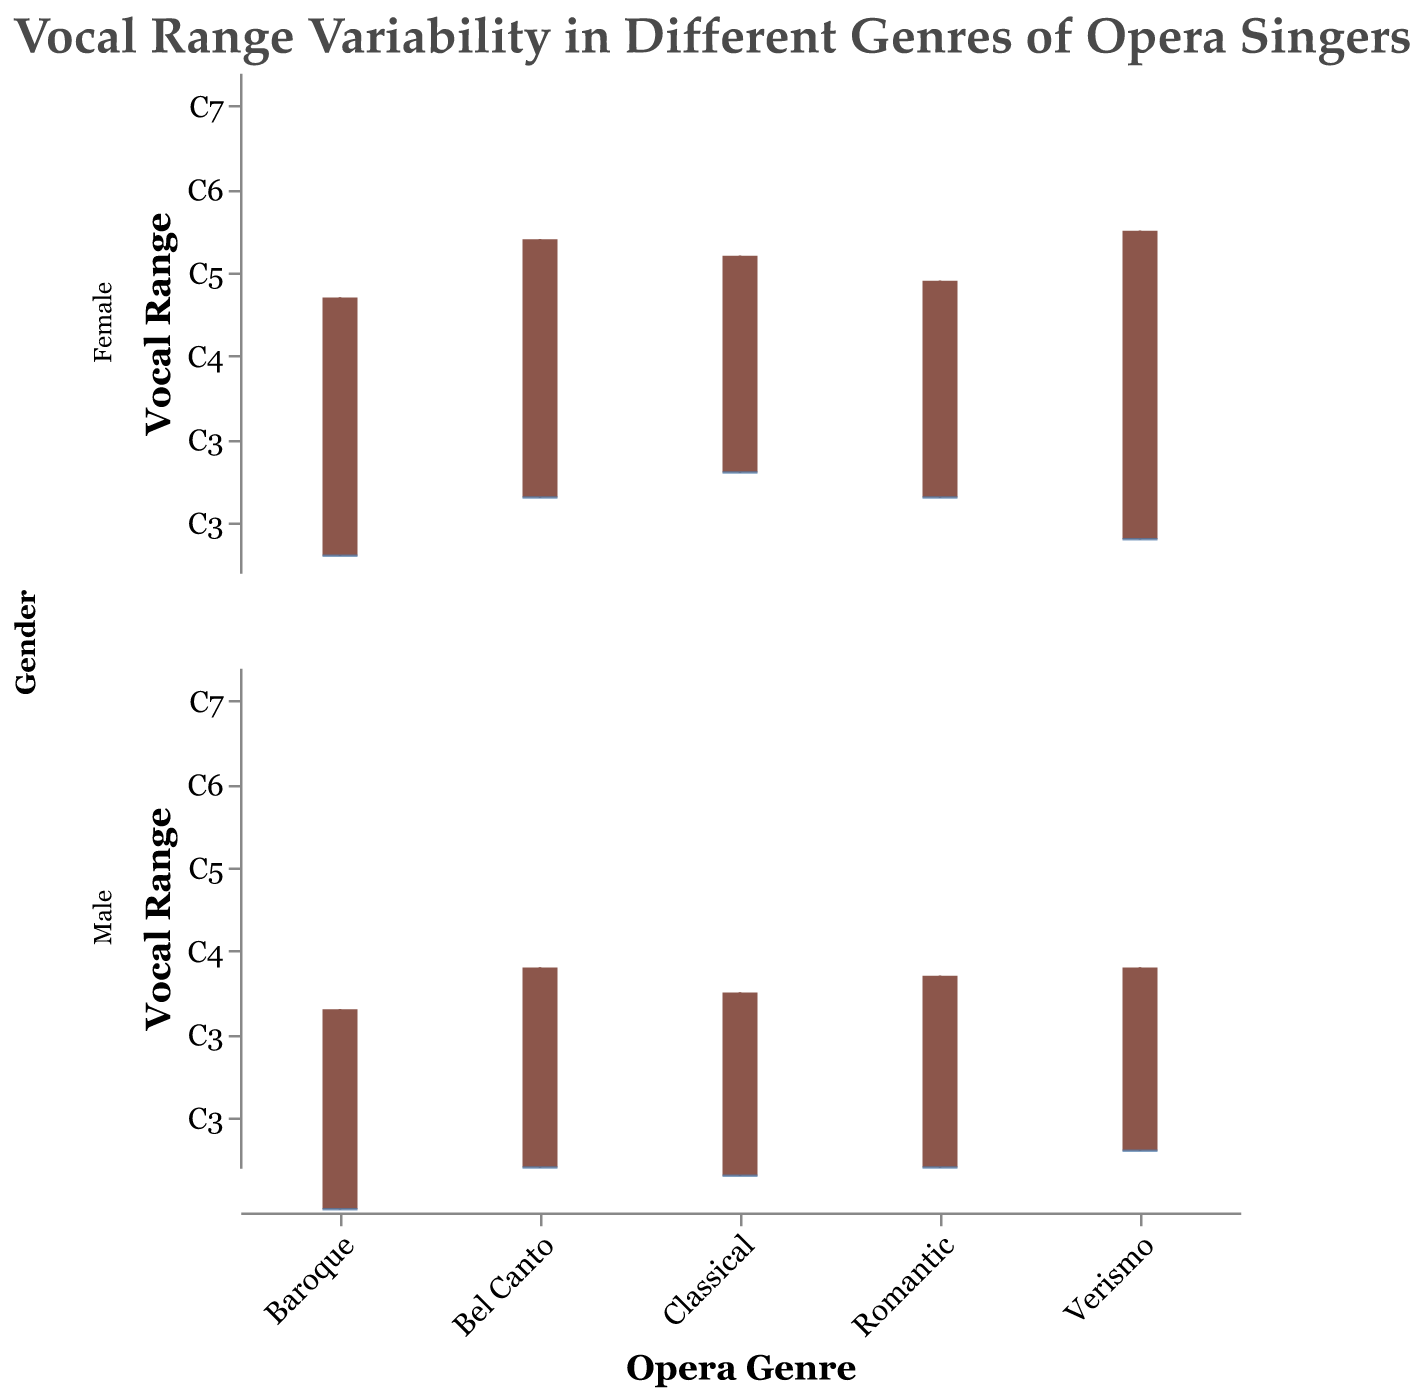Which opera genre has the widest vocal range for female singers? By looking at the box plots for female singers, we compare the lengths of the boxes in each genre. Verismo (Maria Callas) has the widest range extending from E3 to F6.
Answer: Verismo What is the average upper note for male singers across all genres? Listing out the upper notes for male singers: C5, G4, A4, B4, C5. Converting these letters to their numerical equivalents: 60, 55, 69, 71, 72. Summing these values: 60 + 55 + 69 + 71 + 72 = 327. Dividing by 5 (the number of male singers) gives an average of 65.4, which corresponds to the range between C4 and D4.
Answer: 65.4 (C4-D4) Which gender has a more extensive overall vocal range in the "Romantic" genre? For female singers (Angela Gheorghiu), vocal range is from A3 to B5. For male singers (Jonas Kaufmann), the range is from C3 to B4. Comparing total range: Female range (A3-B5) spans more notes than male range (C3-B4).
Answer: Female Are there any genres where the vocal ranges of male and female singers overlap completely? By looking at each genre and comparing male and female vocal ranges:
- Bel Canto: No overlap between C3-C5 for male and A3-E6 for female.
- Baroque: No overlap between G2-G4 for male and D3-A5 for female.
- Classical: No overlap between B2-A4 for male and C4-D6 for female.
- Romantic: No overlap between C3-B4 for male and A3-B5 for female.
- Verismo: Both ranges partly overlap (D3-C5 for male and E3-F6 for female). 
No complete overlaps but partial in Verismo.
Answer: No complete overlaps In which genre do male singers have the narrowest vocal range? Identify the narrowest box plot for male singers:
- Bel Canto: C3-C5
- Baroque: G2-G4
- Classical: B2-A4
- Romantic: C3-B4
- Verismo: D3-C5
Baroque (Andreas Scholl) has the narrowest range with G2 to G4.
Answer: Baroque What is the difference in the median vocal ranges between male and female singers in the "Classical" genre? Female singer (Renée Fleming): C4 to D6. Median of C4-D6 is the midpoint between C4 and D6 which is C5, translating to a numerical median of 60 (C5).
Male singer (Placido Domingo): B2 to A4. Median of B2-A4 is F3, translating to a numerical median of 45 (F3).
Difference: 60 - 45 = 15 notes.
Answer: 15 notes 